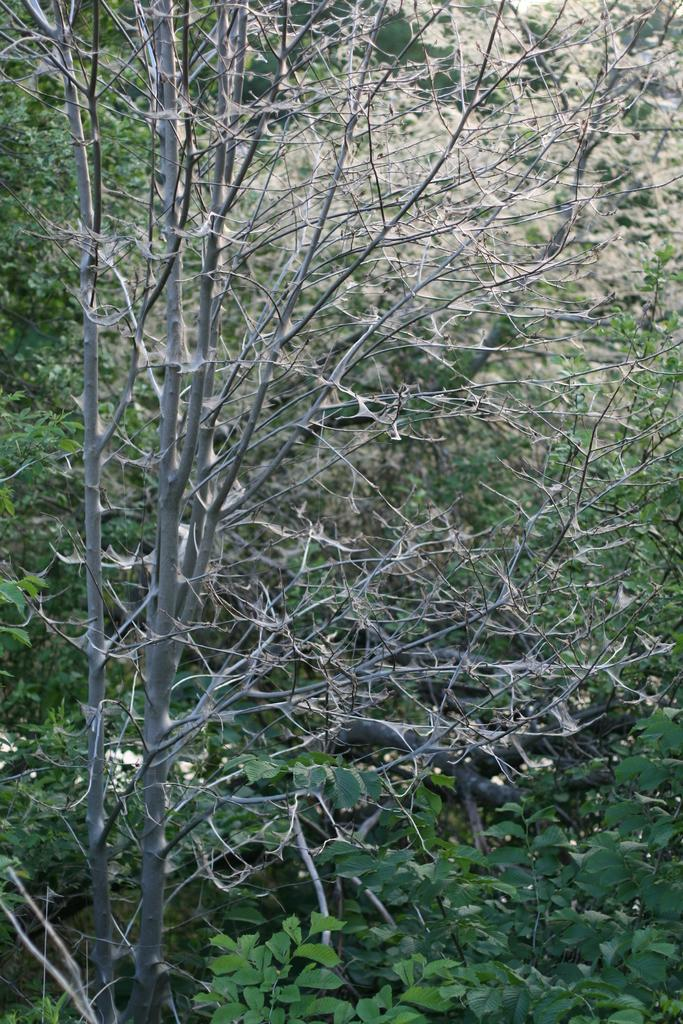What type of vegetation can be seen in the image? There are many trees and numerous plants in the image. Can you describe the density of the vegetation in the image? The image shows a dense concentration of trees and plants. What might be the location of the image based on the vegetation? The image might depict a forest or a garden, given the presence of many trees and plants. What type of joke is being told by the manager in the image? There is no manager or joke present in the image; it only features trees and plants. 